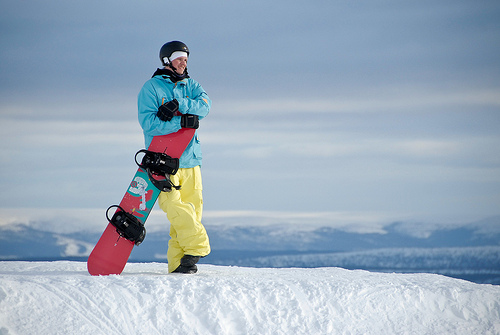Can you describe the clothing of the person? The individual is wearing a bright blue jacket paired with yellow pants, which are both typical snowboarding attire designed for high visibility and protection against the cold and wet snow conditions. Does the attire provide any advantages? Yes, the bright colors enhance visibility on the snowy landscape, which is important for safety. The technical clothing is likely insulated and waterproof, ensuring warmth and dryness while snowboarding. 